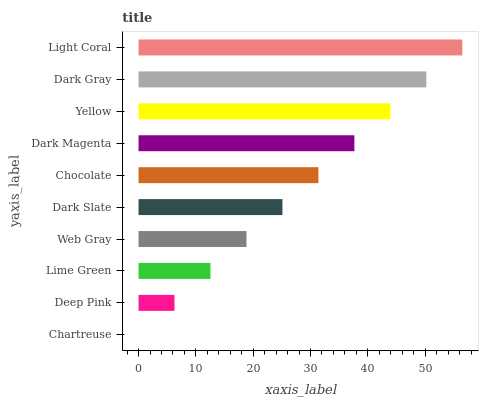Is Chartreuse the minimum?
Answer yes or no. Yes. Is Light Coral the maximum?
Answer yes or no. Yes. Is Deep Pink the minimum?
Answer yes or no. No. Is Deep Pink the maximum?
Answer yes or no. No. Is Deep Pink greater than Chartreuse?
Answer yes or no. Yes. Is Chartreuse less than Deep Pink?
Answer yes or no. Yes. Is Chartreuse greater than Deep Pink?
Answer yes or no. No. Is Deep Pink less than Chartreuse?
Answer yes or no. No. Is Chocolate the high median?
Answer yes or no. Yes. Is Dark Slate the low median?
Answer yes or no. Yes. Is Dark Slate the high median?
Answer yes or no. No. Is Deep Pink the low median?
Answer yes or no. No. 